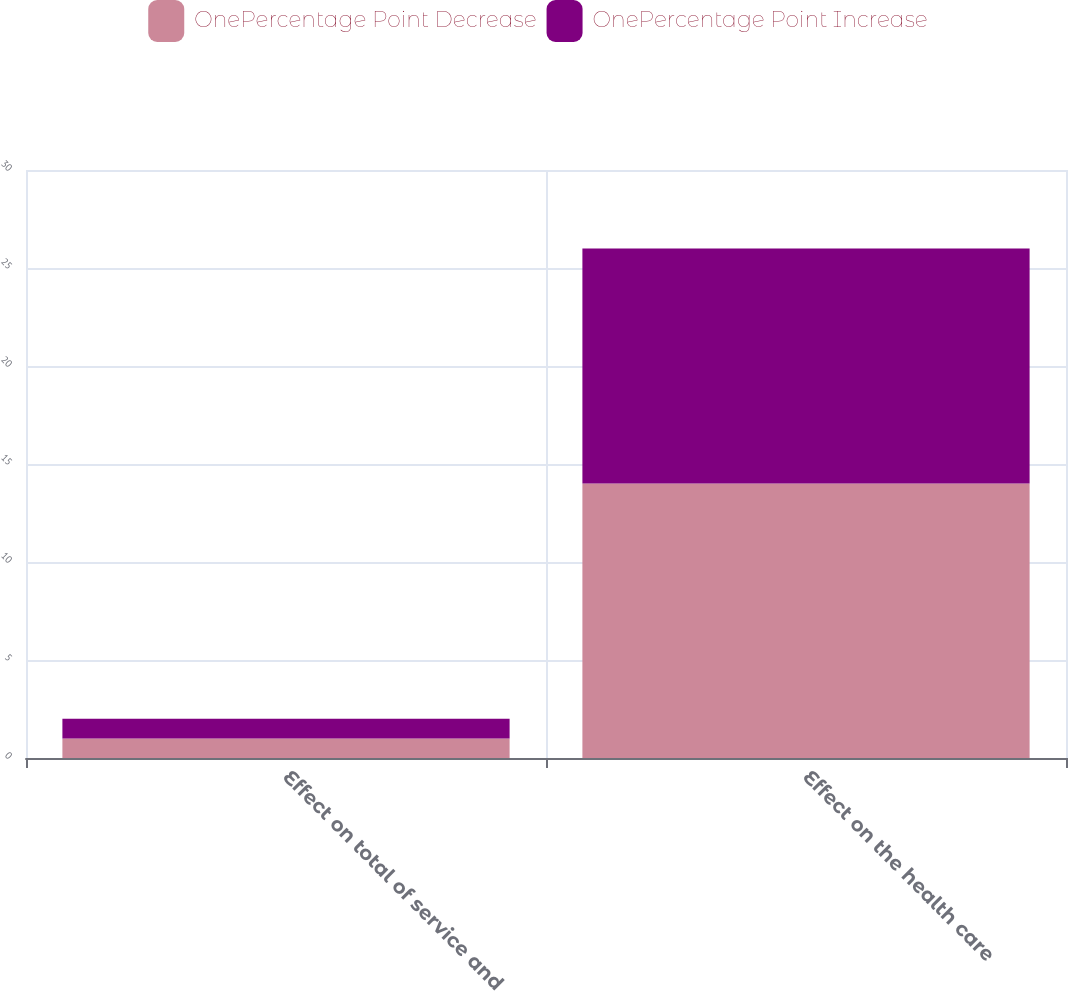Convert chart to OTSL. <chart><loc_0><loc_0><loc_500><loc_500><stacked_bar_chart><ecel><fcel>Effect on total of service and<fcel>Effect on the health care<nl><fcel>OnePercentage Point Decrease<fcel>1<fcel>14<nl><fcel>OnePercentage Point Increase<fcel>1<fcel>12<nl></chart> 